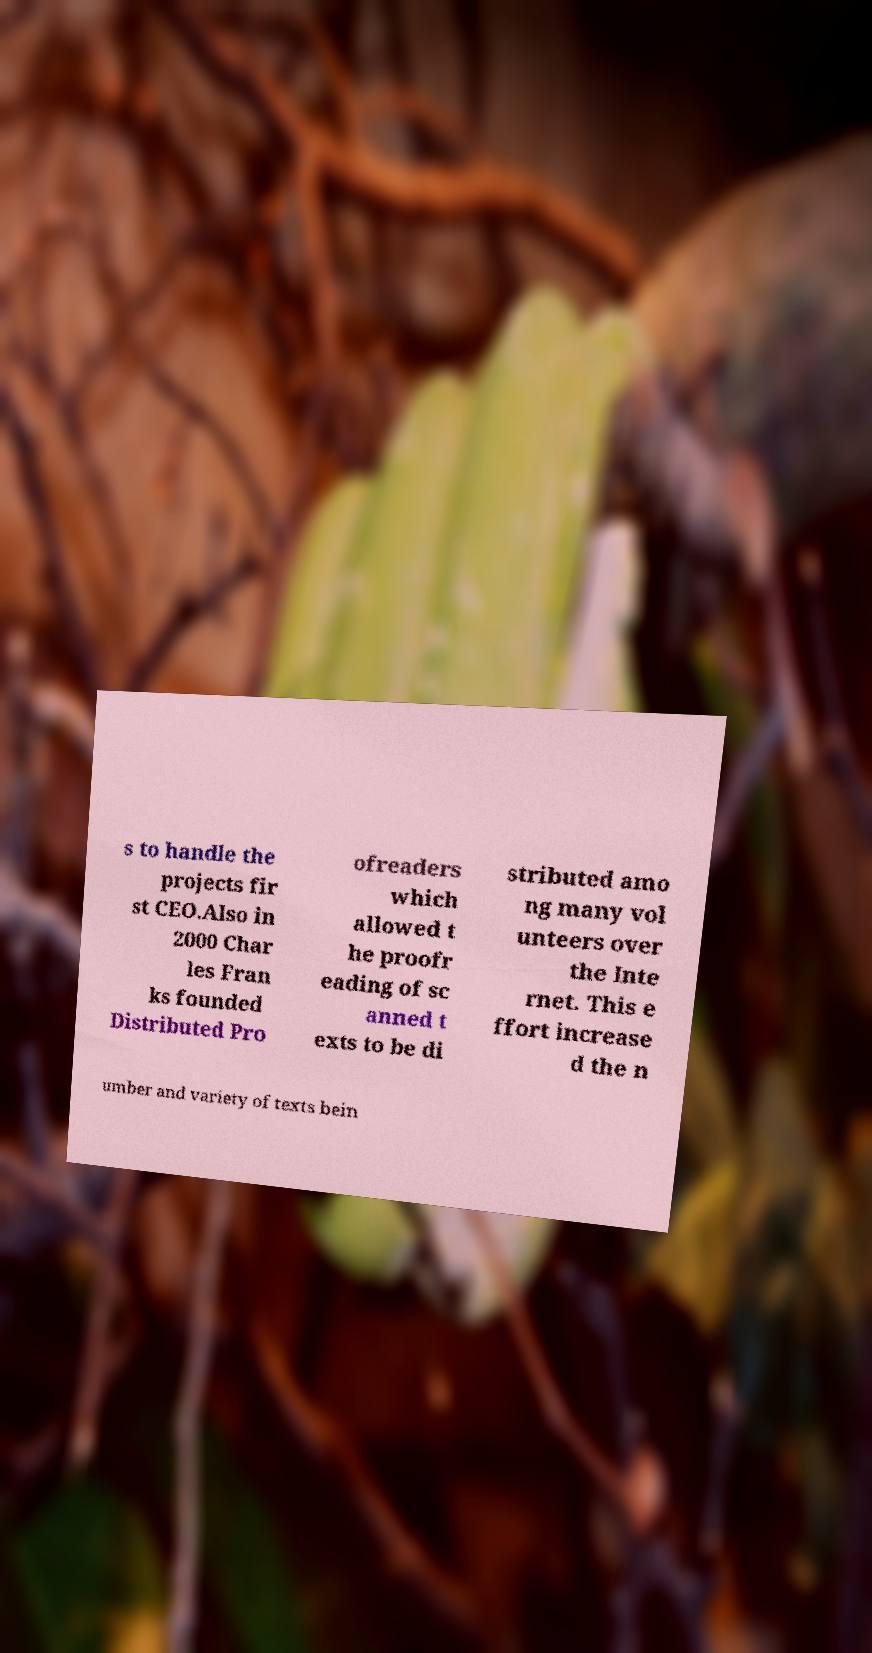Please identify and transcribe the text found in this image. s to handle the projects fir st CEO.Also in 2000 Char les Fran ks founded Distributed Pro ofreaders which allowed t he proofr eading of sc anned t exts to be di stributed amo ng many vol unteers over the Inte rnet. This e ffort increase d the n umber and variety of texts bein 